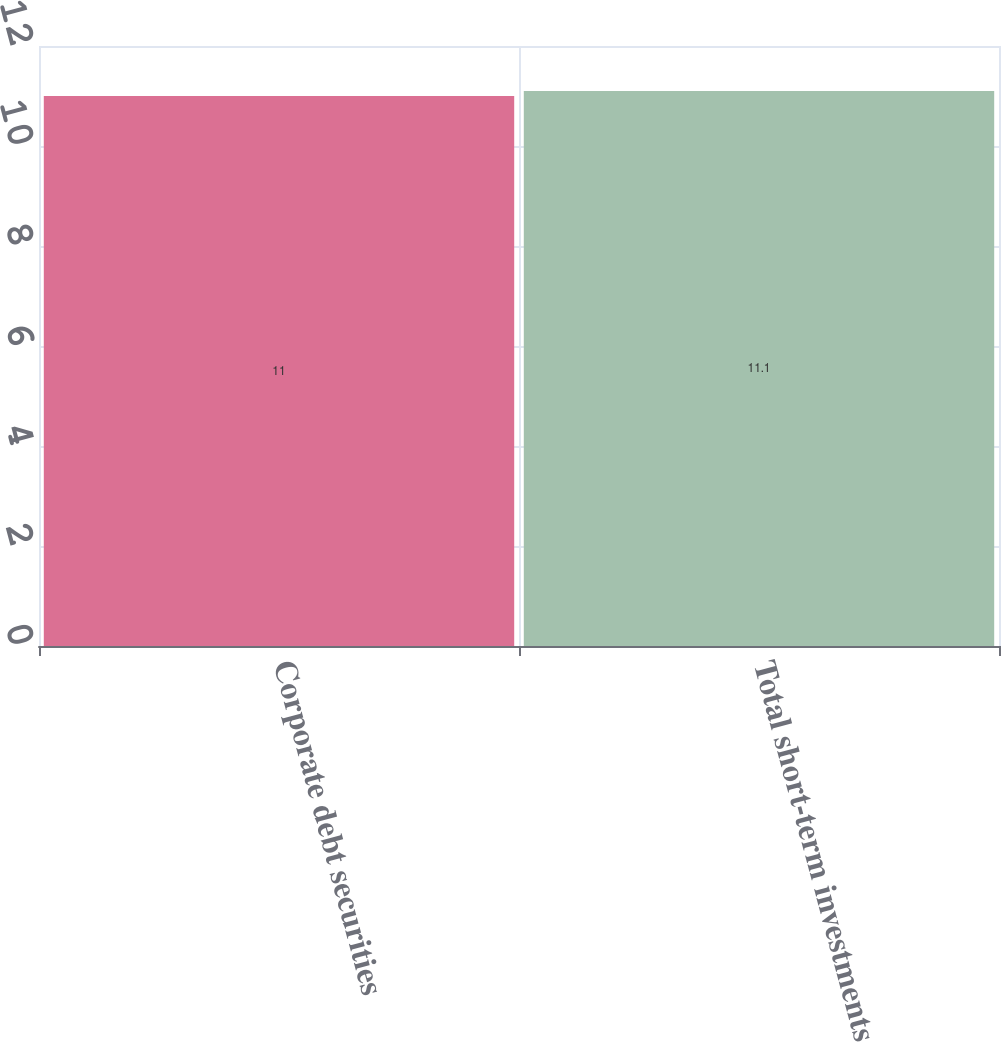Convert chart to OTSL. <chart><loc_0><loc_0><loc_500><loc_500><bar_chart><fcel>Corporate debt securities<fcel>Total short-term investments<nl><fcel>11<fcel>11.1<nl></chart> 